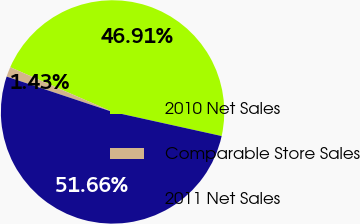<chart> <loc_0><loc_0><loc_500><loc_500><pie_chart><fcel>2010 Net Sales<fcel>Comparable Store Sales<fcel>2011 Net Sales<nl><fcel>46.91%<fcel>1.43%<fcel>51.66%<nl></chart> 